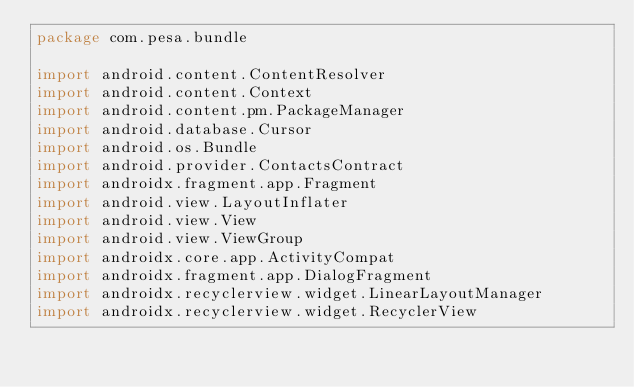Convert code to text. <code><loc_0><loc_0><loc_500><loc_500><_Kotlin_>package com.pesa.bundle

import android.content.ContentResolver
import android.content.Context
import android.content.pm.PackageManager
import android.database.Cursor
import android.os.Bundle
import android.provider.ContactsContract
import androidx.fragment.app.Fragment
import android.view.LayoutInflater
import android.view.View
import android.view.ViewGroup
import androidx.core.app.ActivityCompat
import androidx.fragment.app.DialogFragment
import androidx.recyclerview.widget.LinearLayoutManager
import androidx.recyclerview.widget.RecyclerView</code> 